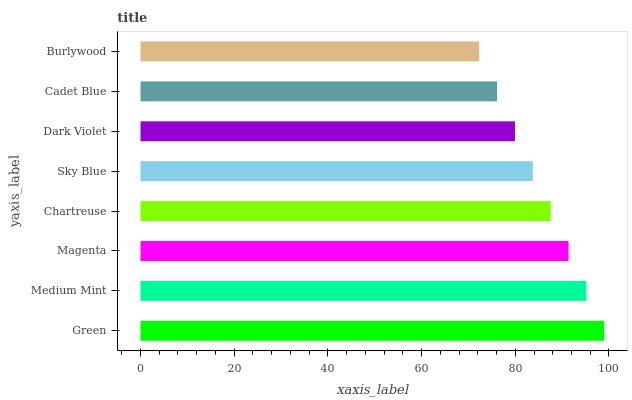Is Burlywood the minimum?
Answer yes or no. Yes. Is Green the maximum?
Answer yes or no. Yes. Is Medium Mint the minimum?
Answer yes or no. No. Is Medium Mint the maximum?
Answer yes or no. No. Is Green greater than Medium Mint?
Answer yes or no. Yes. Is Medium Mint less than Green?
Answer yes or no. Yes. Is Medium Mint greater than Green?
Answer yes or no. No. Is Green less than Medium Mint?
Answer yes or no. No. Is Chartreuse the high median?
Answer yes or no. Yes. Is Sky Blue the low median?
Answer yes or no. Yes. Is Medium Mint the high median?
Answer yes or no. No. Is Burlywood the low median?
Answer yes or no. No. 